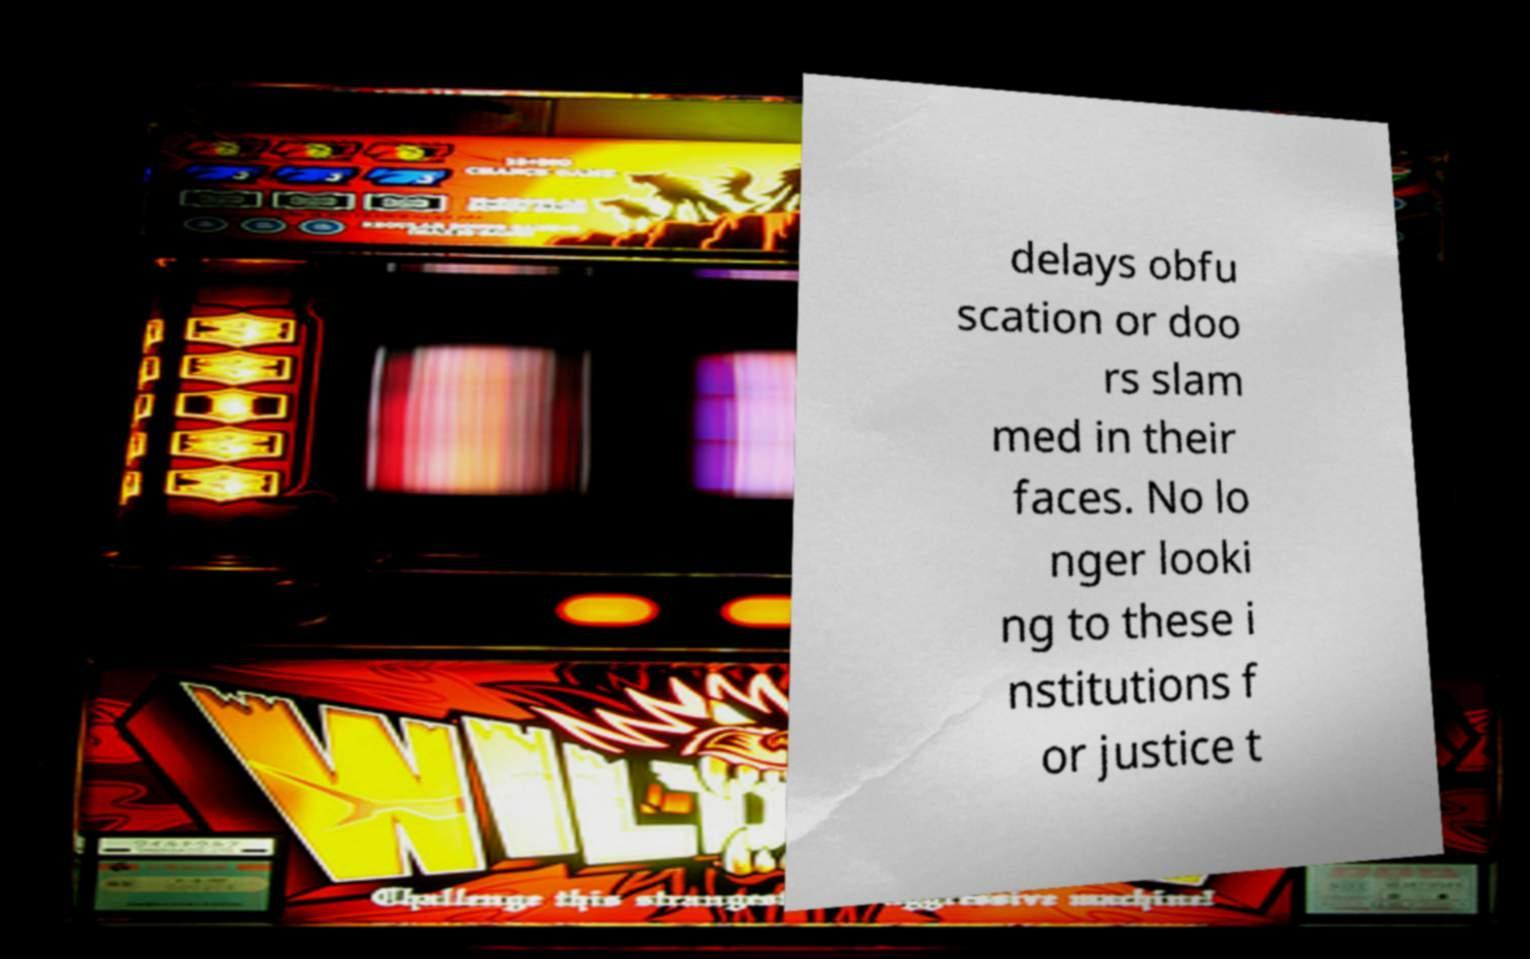For documentation purposes, I need the text within this image transcribed. Could you provide that? delays obfu scation or doo rs slam med in their faces. No lo nger looki ng to these i nstitutions f or justice t 